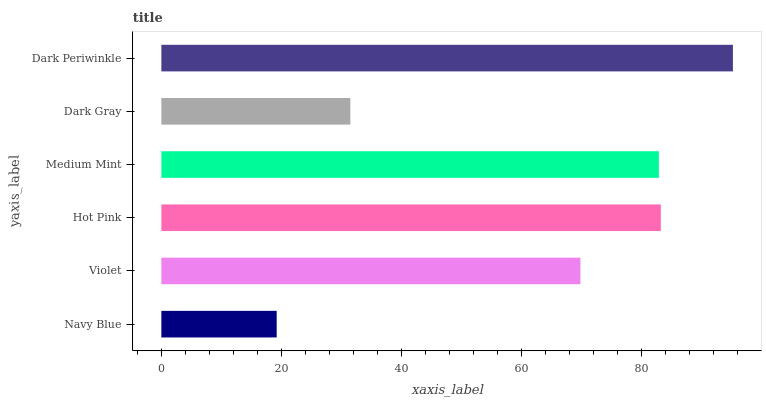Is Navy Blue the minimum?
Answer yes or no. Yes. Is Dark Periwinkle the maximum?
Answer yes or no. Yes. Is Violet the minimum?
Answer yes or no. No. Is Violet the maximum?
Answer yes or no. No. Is Violet greater than Navy Blue?
Answer yes or no. Yes. Is Navy Blue less than Violet?
Answer yes or no. Yes. Is Navy Blue greater than Violet?
Answer yes or no. No. Is Violet less than Navy Blue?
Answer yes or no. No. Is Medium Mint the high median?
Answer yes or no. Yes. Is Violet the low median?
Answer yes or no. Yes. Is Hot Pink the high median?
Answer yes or no. No. Is Hot Pink the low median?
Answer yes or no. No. 